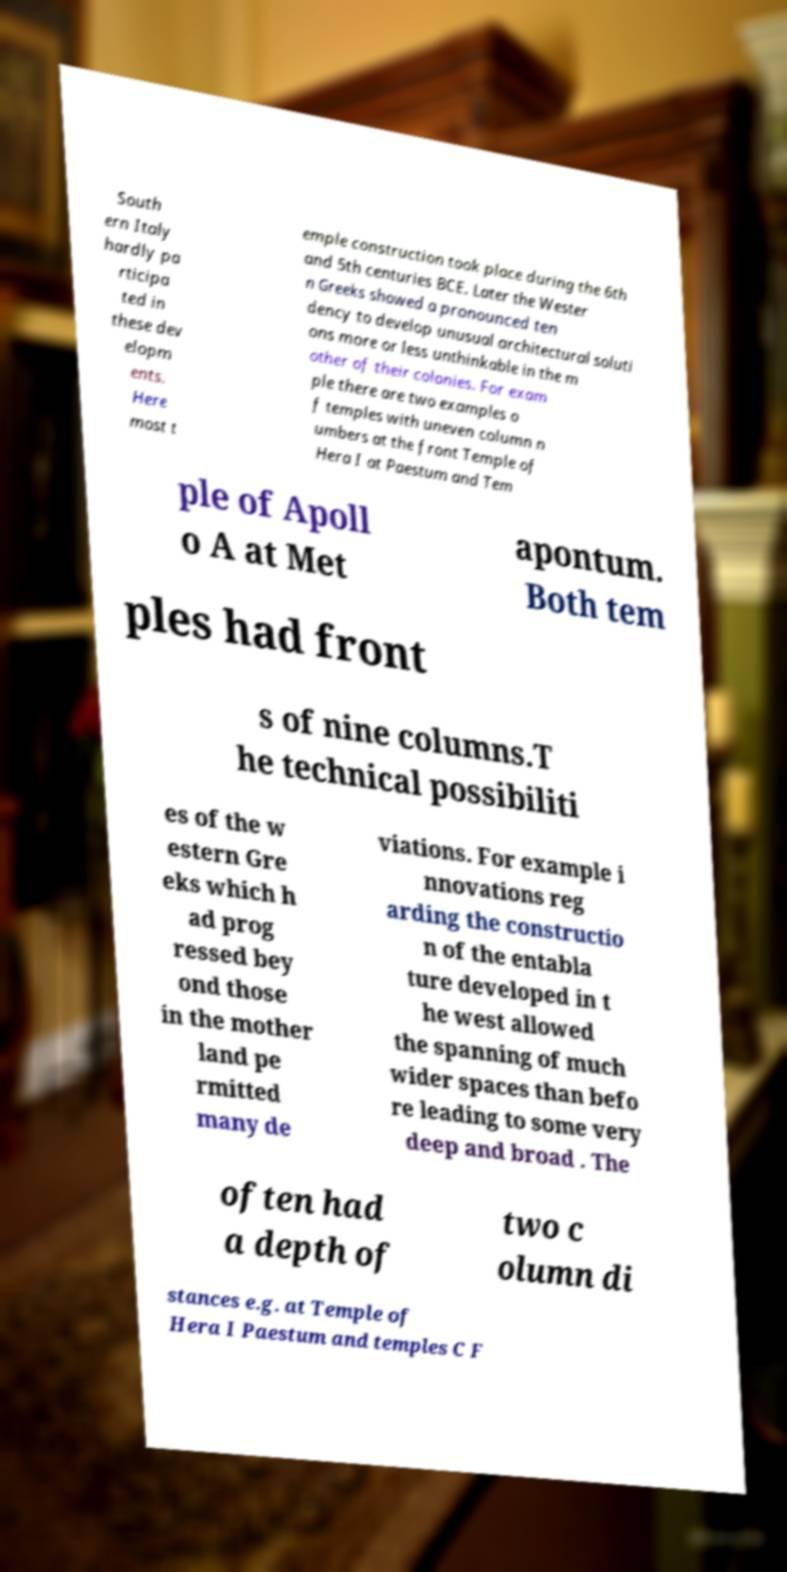For documentation purposes, I need the text within this image transcribed. Could you provide that? South ern Italy hardly pa rticipa ted in these dev elopm ents. Here most t emple construction took place during the 6th and 5th centuries BCE. Later the Wester n Greeks showed a pronounced ten dency to develop unusual architectural soluti ons more or less unthinkable in the m other of their colonies. For exam ple there are two examples o f temples with uneven column n umbers at the front Temple of Hera I at Paestum and Tem ple of Apoll o A at Met apontum. Both tem ples had front s of nine columns.T he technical possibiliti es of the w estern Gre eks which h ad prog ressed bey ond those in the mother land pe rmitted many de viations. For example i nnovations reg arding the constructio n of the entabla ture developed in t he west allowed the spanning of much wider spaces than befo re leading to some very deep and broad . The often had a depth of two c olumn di stances e.g. at Temple of Hera I Paestum and temples C F 